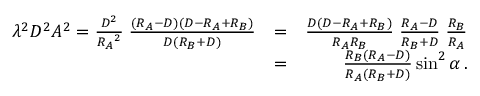Convert formula to latex. <formula><loc_0><loc_0><loc_500><loc_500>\begin{array} { r l r } { \lambda ^ { 2 } D ^ { 2 } A ^ { 2 } = { \frac { D ^ { 2 } } { { R _ { A } } ^ { 2 } } } \, { \frac { ( R _ { A } - D ) ( D - R _ { A } + R _ { B } ) } { D ( R _ { B } + D ) } } } & { = } & { { \frac { D ( D - R _ { A } + R _ { B } ) } { R _ { A } R _ { B } } } \, { \frac { R _ { A } - D } { R _ { B } + D } } \, { \frac { R _ { B } } { R _ { A } } } } \\ & { = } & { { \frac { R _ { B } ( R _ { A } - D ) } { R _ { A } ( R _ { B } + D ) } } \sin ^ { 2 } \alpha \, . } \end{array}</formula> 